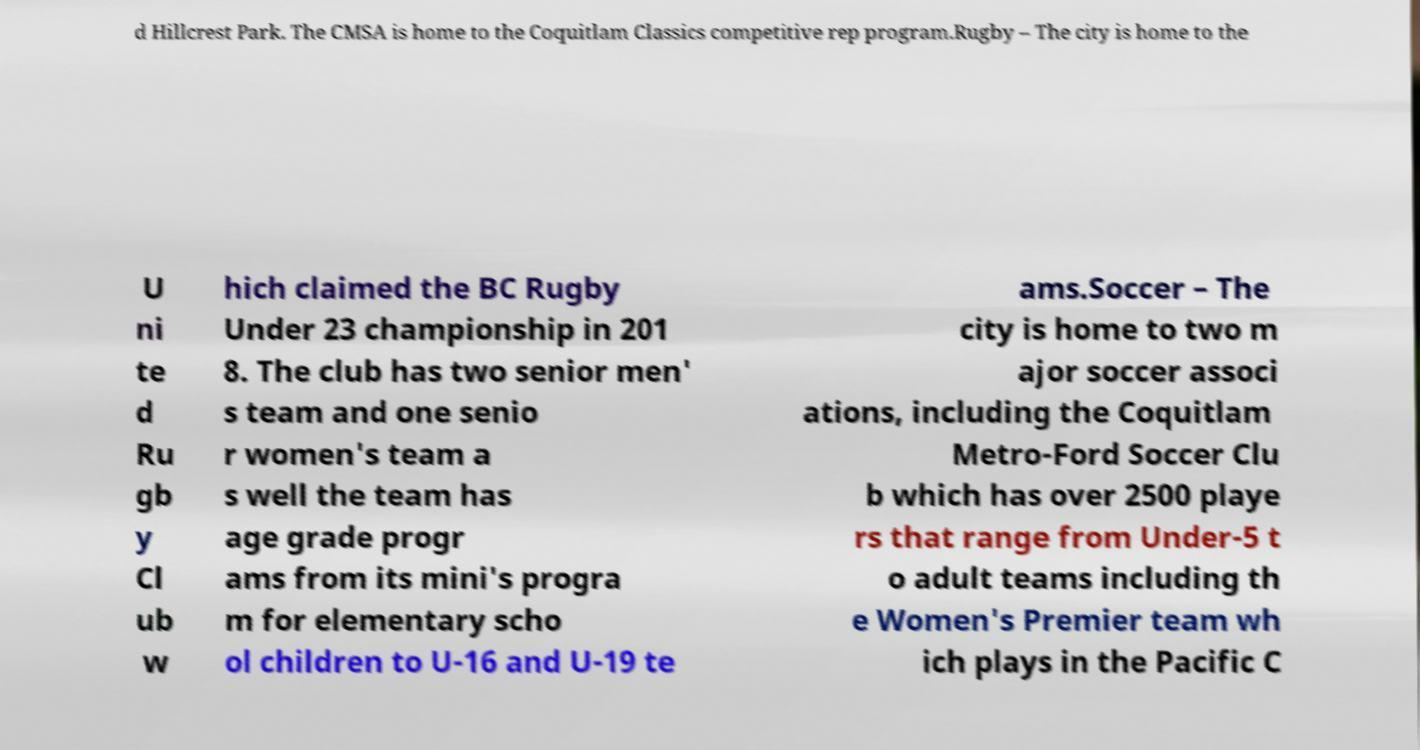Could you extract and type out the text from this image? d Hillcrest Park. The CMSA is home to the Coquitlam Classics competitive rep program.Rugby – The city is home to the U ni te d Ru gb y Cl ub w hich claimed the BC Rugby Under 23 championship in 201 8. The club has two senior men' s team and one senio r women's team a s well the team has age grade progr ams from its mini's progra m for elementary scho ol children to U-16 and U-19 te ams.Soccer – The city is home to two m ajor soccer associ ations, including the Coquitlam Metro-Ford Soccer Clu b which has over 2500 playe rs that range from Under-5 t o adult teams including th e Women's Premier team wh ich plays in the Pacific C 